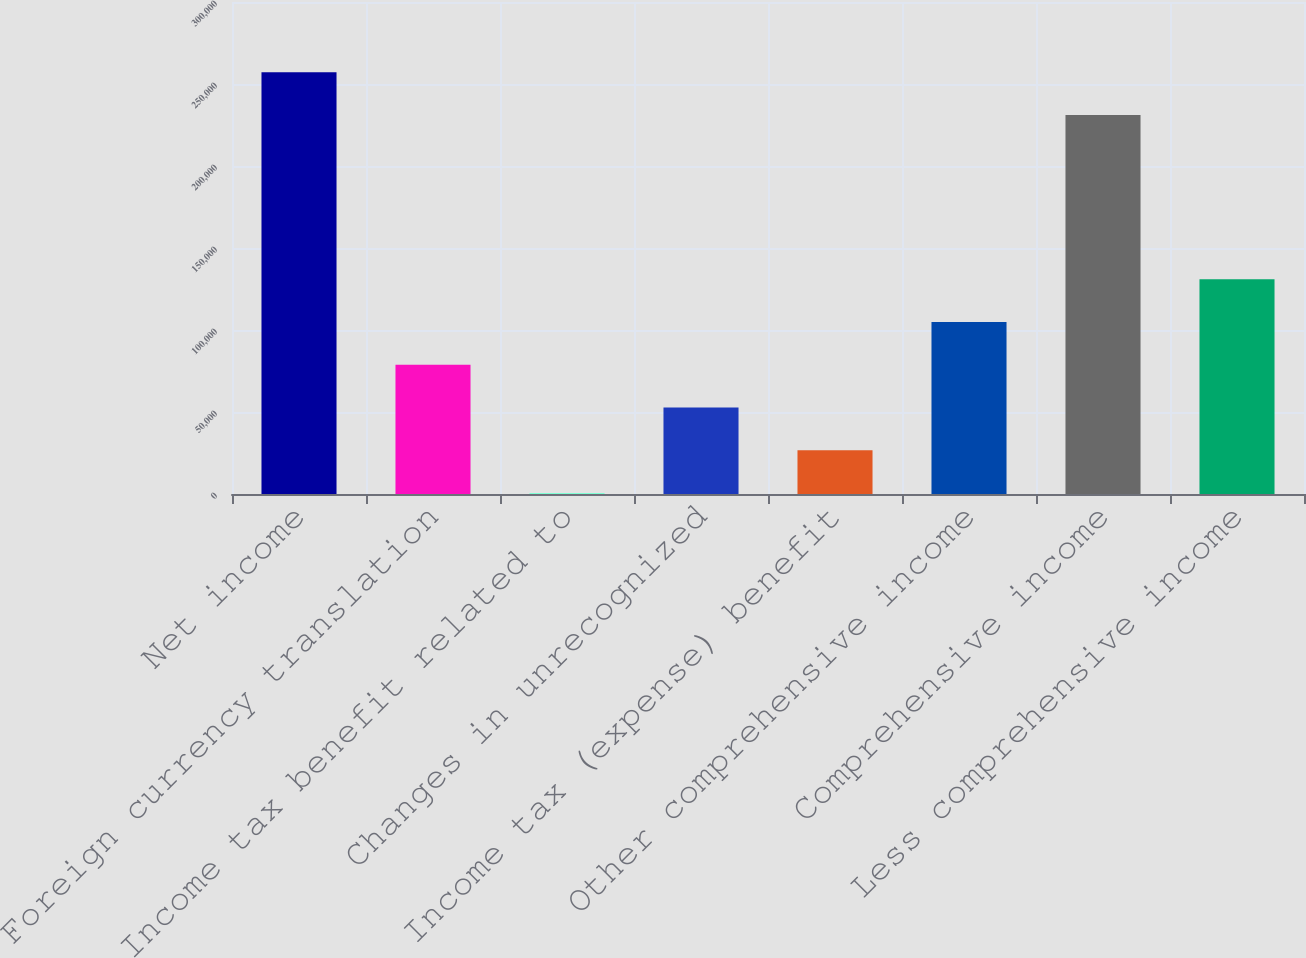<chart> <loc_0><loc_0><loc_500><loc_500><bar_chart><fcel>Net income<fcel>Foreign currency translation<fcel>Income tax benefit related to<fcel>Changes in unrecognized<fcel>Income tax (expense) benefit<fcel>Other comprehensive income<fcel>Comprehensive income<fcel>Less comprehensive income<nl><fcel>257149<fcel>78839.7<fcel>582<fcel>52753.8<fcel>26667.9<fcel>104926<fcel>231063<fcel>131012<nl></chart> 